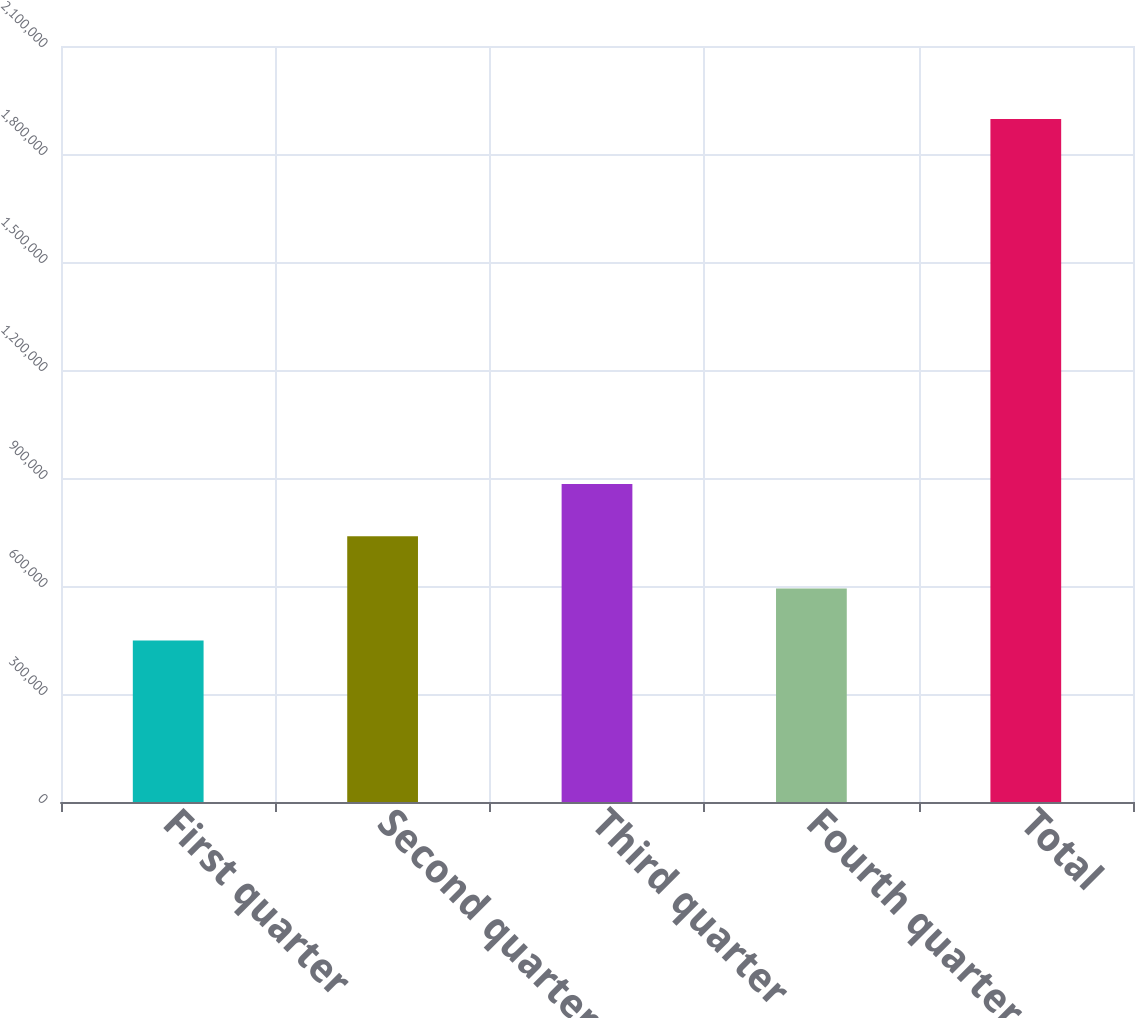Convert chart. <chart><loc_0><loc_0><loc_500><loc_500><bar_chart><fcel>First quarter<fcel>Second quarter<fcel>Third quarter<fcel>Fourth quarter<fcel>Total<nl><fcel>448478<fcel>738263<fcel>883155<fcel>593370<fcel>1.8974e+06<nl></chart> 